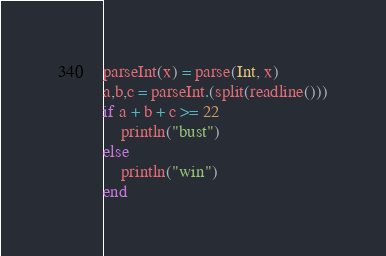Convert code to text. <code><loc_0><loc_0><loc_500><loc_500><_Julia_>parseInt(x) = parse(Int, x)
a,b,c = parseInt.(split(readline()))
if a + b + c >= 22
    println("bust")
else
    println("win")
end</code> 